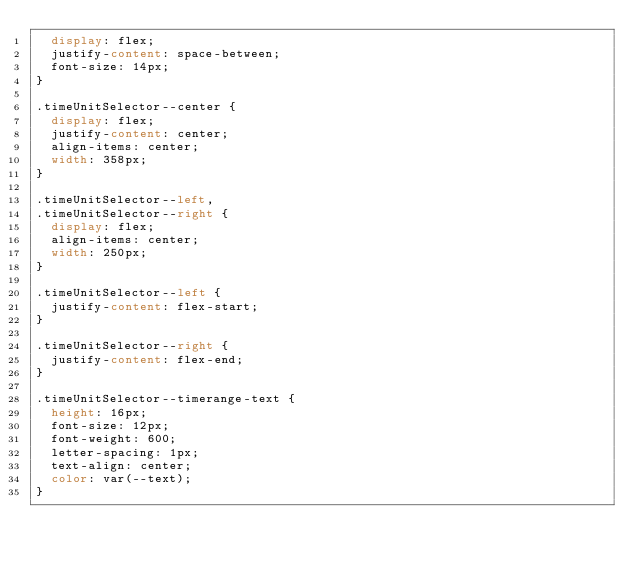Convert code to text. <code><loc_0><loc_0><loc_500><loc_500><_CSS_>  display: flex;
  justify-content: space-between;
  font-size: 14px;
}

.timeUnitSelector--center {
  display: flex;
  justify-content: center;
  align-items: center;
  width: 358px;
}

.timeUnitSelector--left,
.timeUnitSelector--right {
  display: flex;
  align-items: center;
  width: 250px;
}

.timeUnitSelector--left {
  justify-content: flex-start;
}

.timeUnitSelector--right {
  justify-content: flex-end;
}

.timeUnitSelector--timerange-text {
  height: 16px;
  font-size: 12px;
  font-weight: 600;
  letter-spacing: 1px;
  text-align: center;
  color: var(--text);
}
</code> 